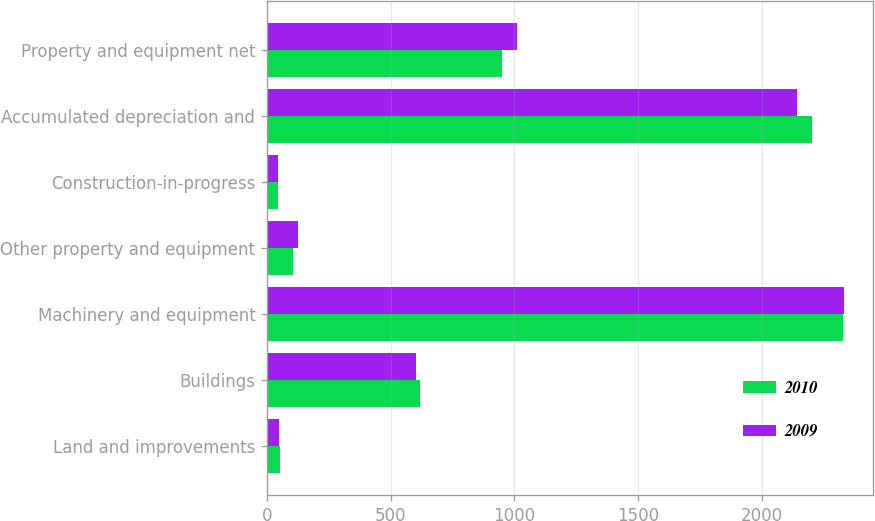Convert chart. <chart><loc_0><loc_0><loc_500><loc_500><stacked_bar_chart><ecel><fcel>Land and improvements<fcel>Buildings<fcel>Machinery and equipment<fcel>Other property and equipment<fcel>Construction-in-progress<fcel>Accumulated depreciation and<fcel>Property and equipment net<nl><fcel>2010<fcel>53<fcel>620.1<fcel>2325.8<fcel>106.3<fcel>43.6<fcel>2200.5<fcel>948.3<nl><fcel>2009<fcel>49.7<fcel>604.1<fcel>2332<fcel>124.1<fcel>42.7<fcel>2141.9<fcel>1010.7<nl></chart> 